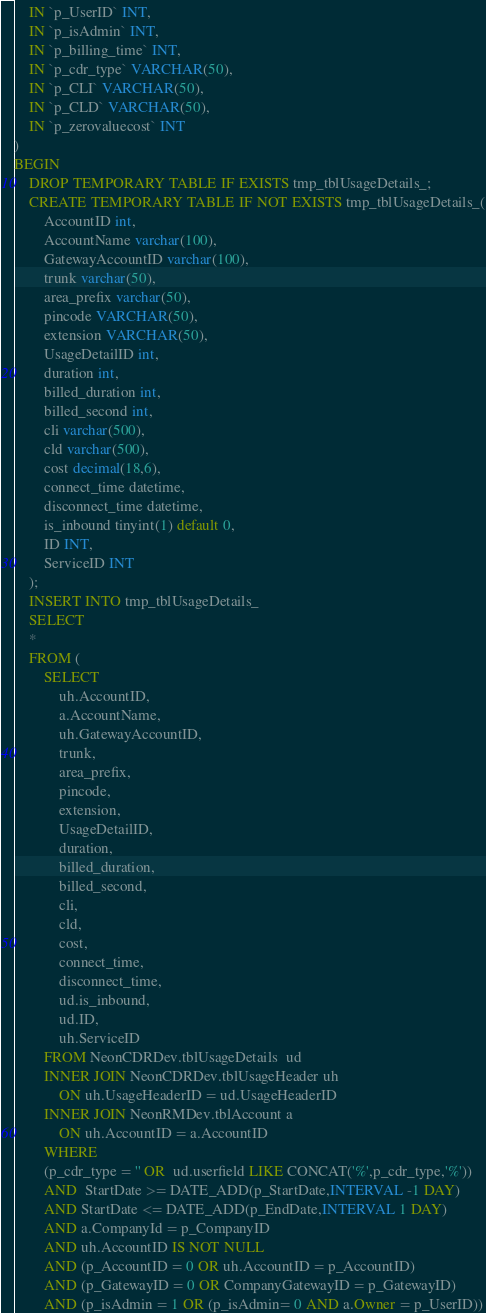<code> <loc_0><loc_0><loc_500><loc_500><_SQL_>	IN `p_UserID` INT,
	IN `p_isAdmin` INT,
	IN `p_billing_time` INT,
	IN `p_cdr_type` VARCHAR(50),
	IN `p_CLI` VARCHAR(50),
	IN `p_CLD` VARCHAR(50),
	IN `p_zerovaluecost` INT
)
BEGIN
	DROP TEMPORARY TABLE IF EXISTS tmp_tblUsageDetails_;
	CREATE TEMPORARY TABLE IF NOT EXISTS tmp_tblUsageDetails_(
		AccountID int,
		AccountName varchar(100),
		GatewayAccountID varchar(100),
		trunk varchar(50),
		area_prefix varchar(50),
		pincode VARCHAR(50),
		extension VARCHAR(50),
		UsageDetailID int,
		duration int,
		billed_duration int,
		billed_second int,
		cli varchar(500),
		cld varchar(500),
		cost decimal(18,6),
		connect_time datetime,
		disconnect_time datetime,
		is_inbound tinyint(1) default 0,
		ID INT,
		ServiceID INT
	);
	INSERT INTO tmp_tblUsageDetails_
	SELECT
	*
	FROM (
		SELECT
			uh.AccountID,
			a.AccountName,
			uh.GatewayAccountID,
			trunk,
			area_prefix,
			pincode,
			extension,
			UsageDetailID,
			duration,
			billed_duration,
			billed_second,
			cli,
			cld,
			cost,
			connect_time,
			disconnect_time,
			ud.is_inbound,
			ud.ID,
			uh.ServiceID
		FROM NeonCDRDev.tblUsageDetails  ud
		INNER JOIN NeonCDRDev.tblUsageHeader uh
			ON uh.UsageHeaderID = ud.UsageHeaderID
		INNER JOIN NeonRMDev.tblAccount a
			ON uh.AccountID = a.AccountID
		WHERE
		(p_cdr_type = '' OR  ud.userfield LIKE CONCAT('%',p_cdr_type,'%'))
		AND  StartDate >= DATE_ADD(p_StartDate,INTERVAL -1 DAY)
		AND StartDate <= DATE_ADD(p_EndDate,INTERVAL 1 DAY)
		AND a.CompanyId = p_CompanyID
		AND uh.AccountID IS NOT NULL
		AND (p_AccountID = 0 OR uh.AccountID = p_AccountID)
		AND (p_GatewayID = 0 OR CompanyGatewayID = p_GatewayID)
		AND (p_isAdmin = 1 OR (p_isAdmin= 0 AND a.Owner = p_UserID))</code> 